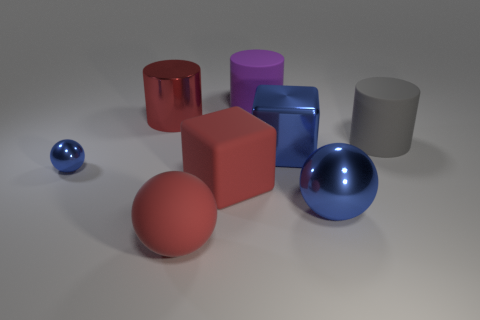Add 1 large gray rubber cylinders. How many objects exist? 9 Subtract all green cylinders. Subtract all green balls. How many cylinders are left? 3 Subtract all spheres. How many objects are left? 5 Subtract 0 brown balls. How many objects are left? 8 Subtract all large blue balls. Subtract all big blue spheres. How many objects are left? 6 Add 8 red rubber things. How many red rubber things are left? 10 Add 2 red rubber blocks. How many red rubber blocks exist? 3 